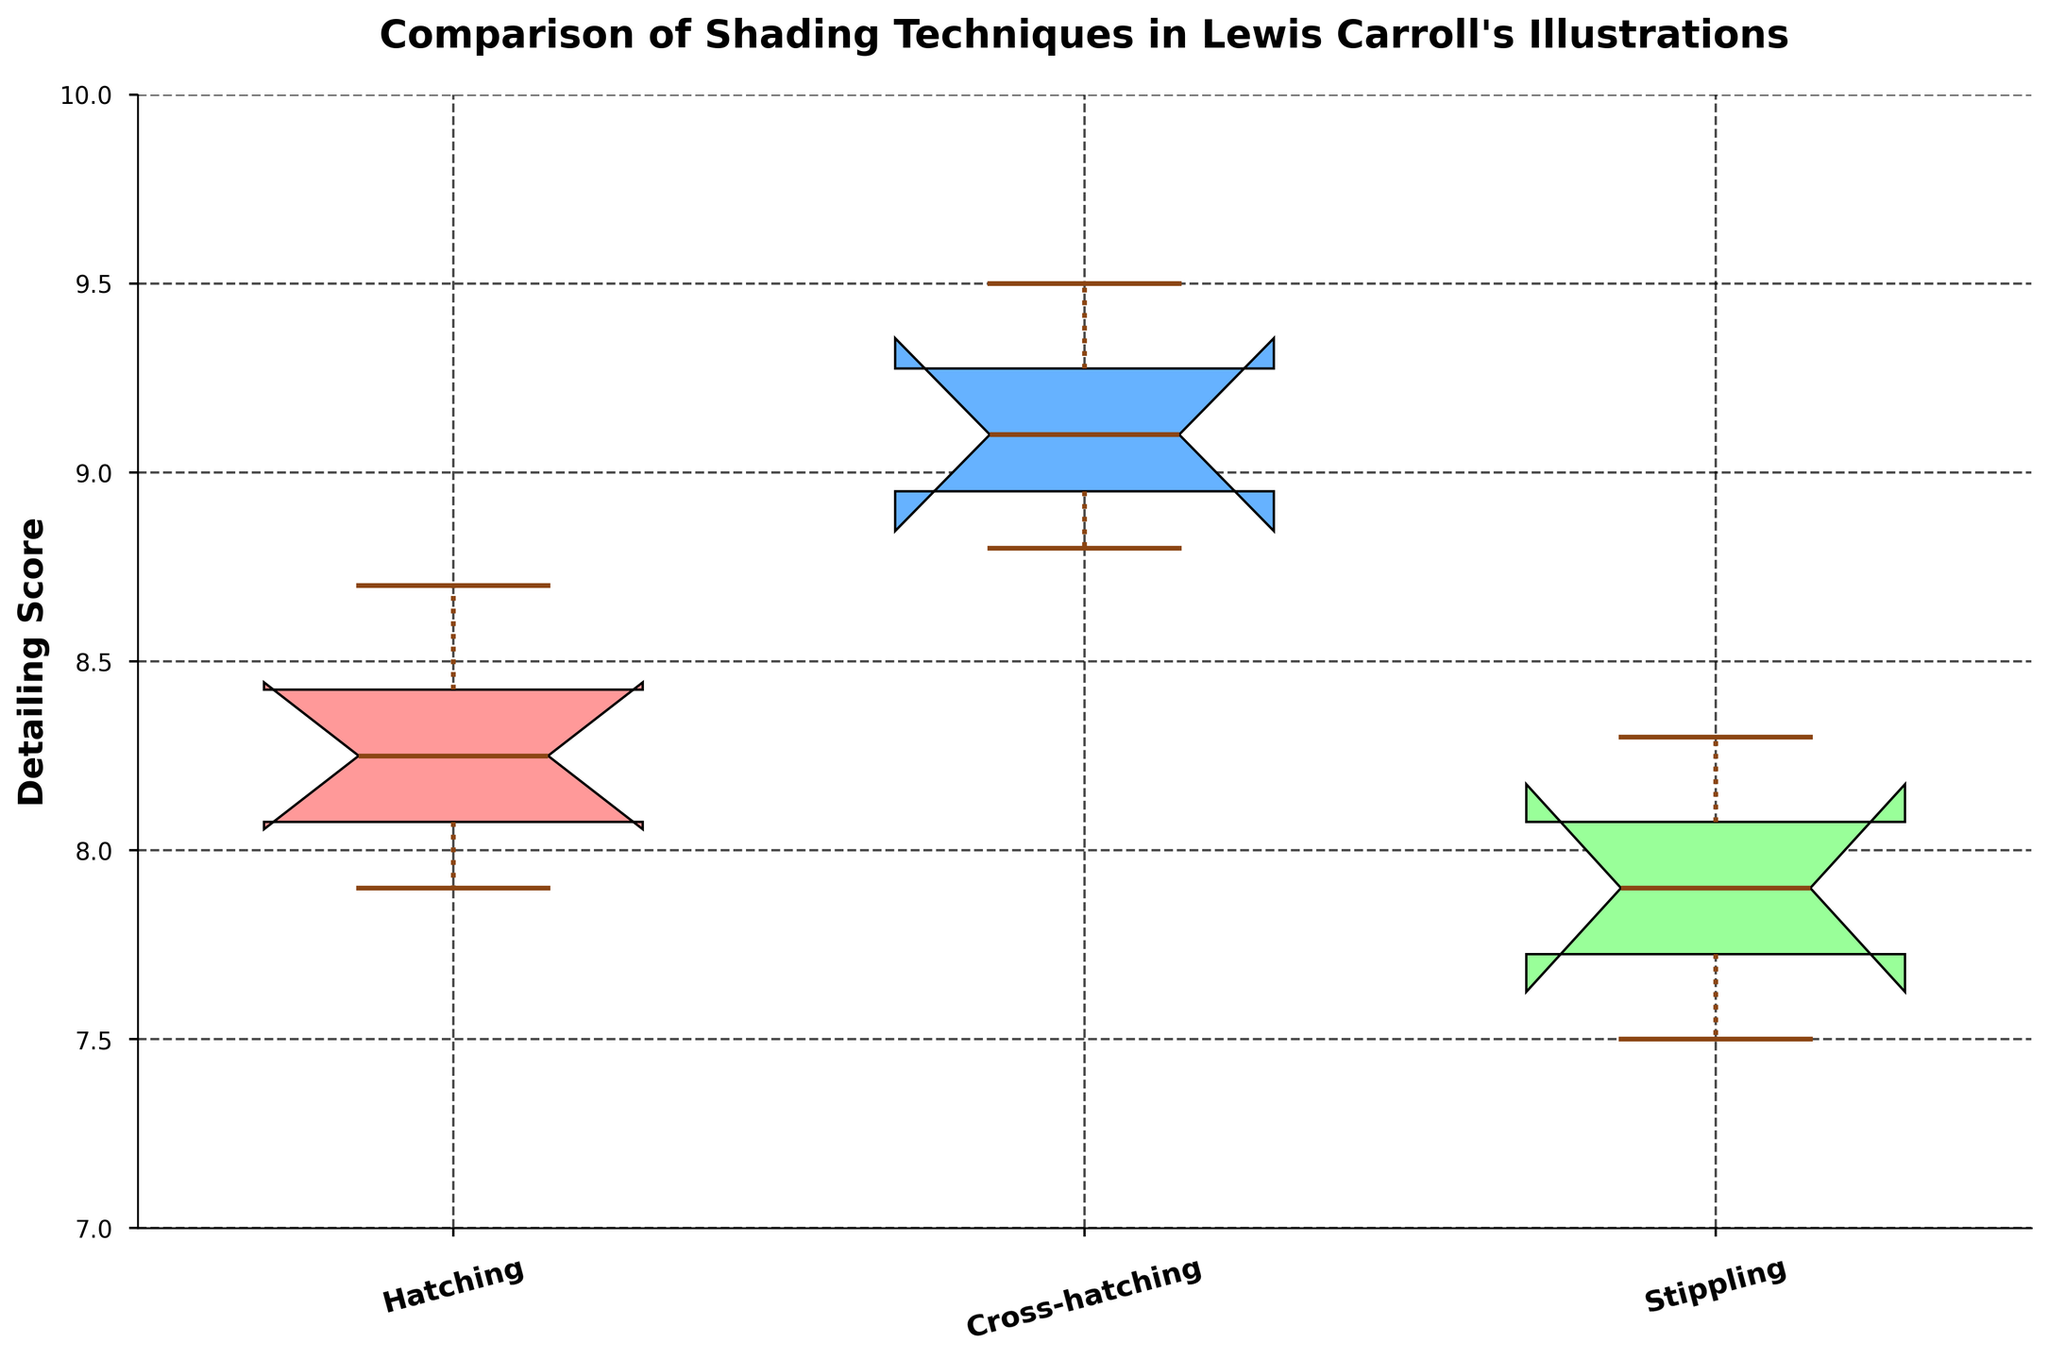Which shading technique has the highest median detailing score? The median of each shading technique can be identified by the middle line inside the boxes. The Cross-hatching technique has the highest median, as its median line is positioned higher than that of Hatching, Stippling, and Hatching techniques.
Answer: Cross-hatching How many shading techniques are compared in the plot? Look at the number of unique box plots on the x-axis. Each box plot represents a shading technique. There are four unique shading techniques presented.
Answer: Four Which shading technique shows the greatest variability in detailing scores? The variability in detailing scores is represented by the length of the boxes and whiskers. The Cross-hatching technique shows the greatest variability as the distance between the whiskers is the longest.
Answer: Cross-hatching What is the approximate detailing score range for the Hatching technique? To find the range, look at the lower and upper whiskers for the Hatching box plot. The range extends from the lowest whisker around 8.0 to the highest whisker near 8.7.
Answer: 8.0 to 8.7 Which shading technique has the lowest minimum detailing score? The minimum detailing score is the lowest point of the lower whisker. The Stippling technique has the lowest minimum score with its whisker extending to around 7.5.
Answer: Stippling Are the detailing scores of Cross-hatching and Stippling significantly different based on the notches? In a notched box plot, if the notches of two box plots don't overlap, their medians are significantly different. The notches of Cross-hatching and Stippling do not overlap, indicating a significant difference.
Answer: Yes Is there any shading technique where an outlier is present? Outliers are represented by individual points outside of the whiskers in a box plot. The Cross-hatching technique features an outlier marked by red circles outside the whisker range.
Answer: Yes Which shading technique has the smallest interquartile range (IQR)? The IQR is represented by the height of the box (distance between the lower and upper quartiles). Hatching has the smallest IQR.
Answer: Hatching Do all the shading techniques show at least one instance of the detailing score above 8.0? Evaluate the data range of the boxes and whiskers for each shading technique. All shading techniques have their lower whiskers at or above 8.0.
Answer: Yes 